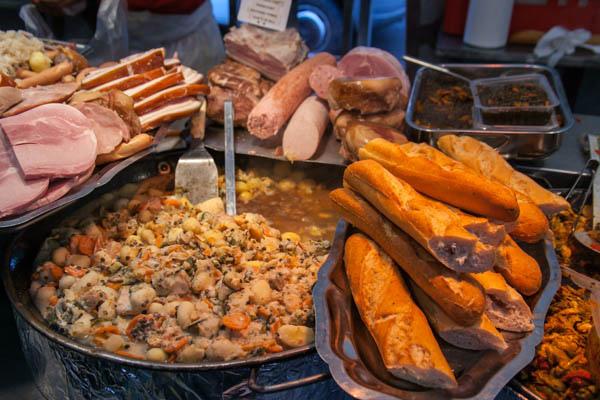What is this supposed to be?
Be succinct. Food. Is it a pizza?
Short answer required. No. What is being sold at this store?
Short answer required. Food. What color are the serving tongs?
Write a very short answer. Silver. Do you see a ham?
Keep it brief. Yes. Does this look like a market?
Concise answer only. Yes. 